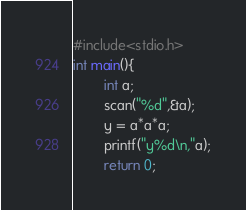Convert code to text. <code><loc_0><loc_0><loc_500><loc_500><_C_>#include<stdio.h>
int main(){
        int a;
        scan("%d",&a);
        y = a*a*a;
        printf("y%d\n,"a);
        return 0;</code> 